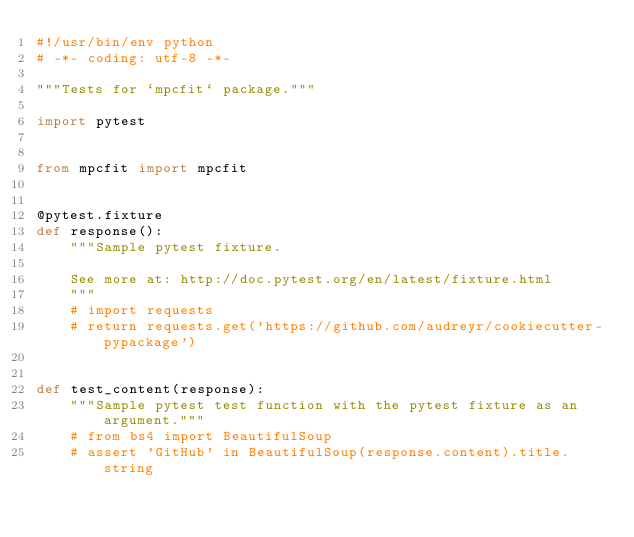Convert code to text. <code><loc_0><loc_0><loc_500><loc_500><_Python_>#!/usr/bin/env python
# -*- coding: utf-8 -*-

"""Tests for `mpcfit` package."""

import pytest


from mpcfit import mpcfit


@pytest.fixture
def response():
    """Sample pytest fixture.

    See more at: http://doc.pytest.org/en/latest/fixture.html
    """
    # import requests
    # return requests.get('https://github.com/audreyr/cookiecutter-pypackage')


def test_content(response):
    """Sample pytest test function with the pytest fixture as an argument."""
    # from bs4 import BeautifulSoup
    # assert 'GitHub' in BeautifulSoup(response.content).title.string
</code> 